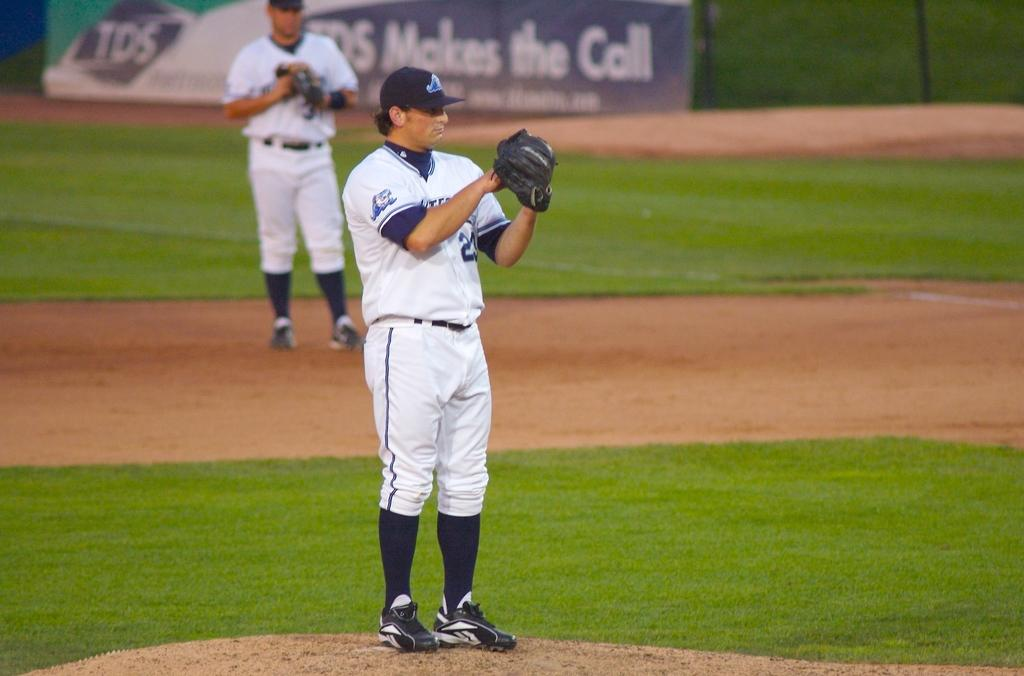What can be seen in the image? There is a person in the image. What is the person wearing on their head? The person is wearing a cap. What is the person wearing on their hand? The person is wearing a glove. What type of surface is visible in the image? There is ground visible in the image. What type of vegetation is present in the image? There is grass in the image. Can you describe the background of the image? There is another person and a hoarding in the background of the image. What type of ear is visible on the person in the image? There is no ear visible on the person in the image; the person is wearing a cap that covers their ears. 